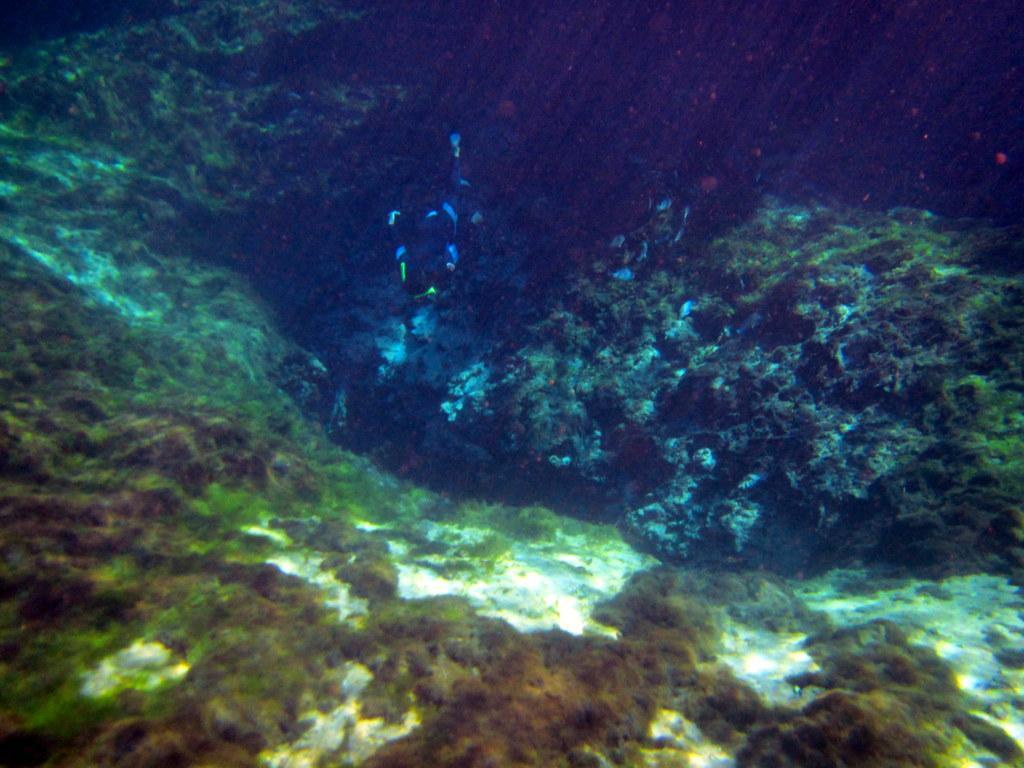Please provide a concise description of this image. Under a large water body, there is some creature swimming in between the plants. 